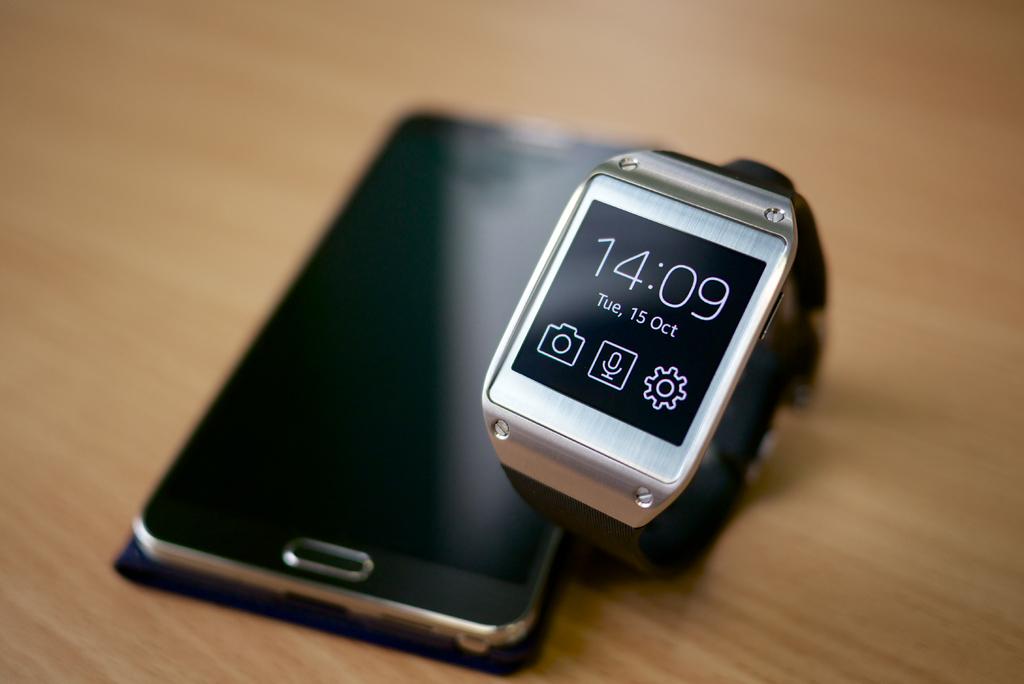What time does it say?
Provide a short and direct response. 14:09. What is the date on the watch?
Offer a terse response. 15 oct. 